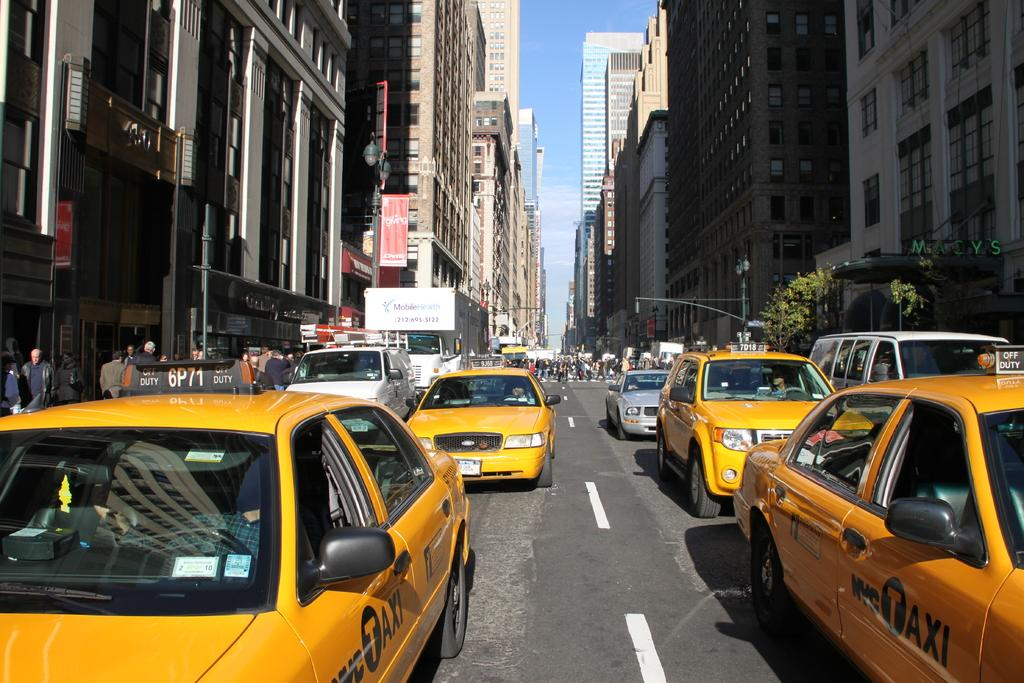<image>
Offer a succinct explanation of the picture presented. A truck from Mobile Health on the street behind NYC taxis and other vehicles. 